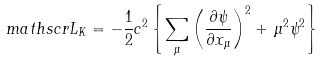<formula> <loc_0><loc_0><loc_500><loc_500>\ m a t h s c r { L } _ { K } = - \frac { 1 } { 2 } c ^ { 2 } \left \{ \sum _ { \mu } \left ( \frac { \partial \psi } { \partial x _ { \mu } } \right ) ^ { 2 } + \, \mu ^ { 2 } \psi ^ { 2 } \right \}</formula> 